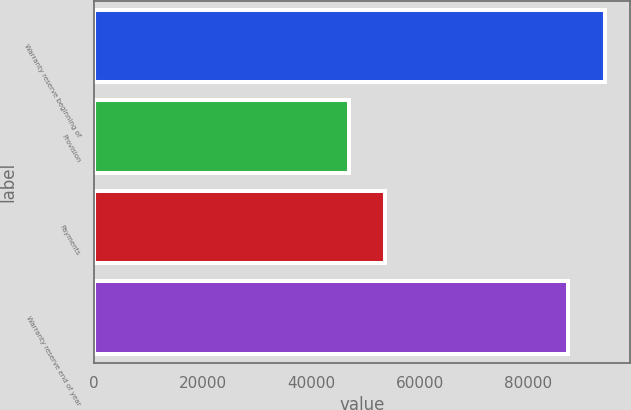Convert chart to OTSL. <chart><loc_0><loc_0><loc_500><loc_500><bar_chart><fcel>Warranty reserve beginning of<fcel>Provision<fcel>Payments<fcel>Warranty reserve end of year<nl><fcel>94060<fcel>47003<fcel>53656<fcel>87407<nl></chart> 